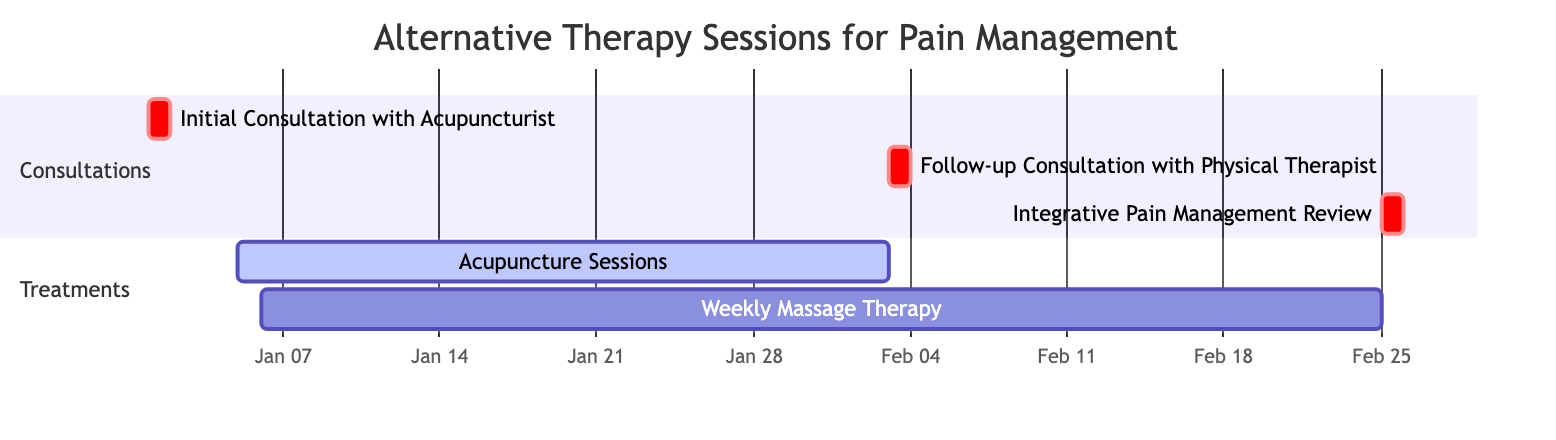What is the duration of the Acupuncture Sessions? The diagram indicates that the Acupuncture Sessions start on January 5, 2024, and end on February 2, 2024. Counting the days between these two dates gives a total of 29 days for the session duration.
Answer: 29 days When is the Initial Consultation with the Acupuncturist scheduled? The Gantt chart shows that the Initial Consultation with the Acupuncturist is scheduled for January 1, 2024, as indicated by the start and end date for that task.
Answer: January 1, 2024 How many separate consultations are scheduled? Analyzing the section labeled "Consultations" in the chart, we see there are three separate consultations: the Initial Consultation, the Follow-up Consultation, and the Integrative Pain Management Review. Thus, the total number of consultations is three.
Answer: 3 What is the start date of the Weekly Massage Therapy? By checking the diagram, the Weekly Massage Therapy begins on January 6, 2024, which is clearly marked as the start date in the chart.
Answer: January 6, 2024 Which treatment has a longer duration, Acupuncture Sessions or Weekly Massage Therapy? The Gantt chart shows that Acupuncture Sessions last for 29 days, while Weekly Massage Therapy lasts for 50 days, making the Weekly Massage Therapy the longer session by 21 days.
Answer: Weekly Massage Therapy What task follows the Acupuncture Sessions? Looking at the timeline in the diagram, after the Acupuncture Sessions conclude on February 2, there is a Follow-up Consultation with the Physical Therapist scheduled for February 3, 2024, indicating it directly follows the sessions.
Answer: Follow-up Consultation with Physical Therapist How many treatments are indicated in the diagram? In the "Treatments" section of the Gantt chart, two separate treatments are listed: Acupuncture Sessions and Weekly Massage Therapy, confirming that there are exactly two treatments outlined in the diagram.
Answer: 2 What is the end date for the Integrative Pain Management Review? The diagram specifies that the Integrative Pain Management Review occurs on February 25, 2024, which is marked as both the start and end date for that task.
Answer: February 25, 2024 